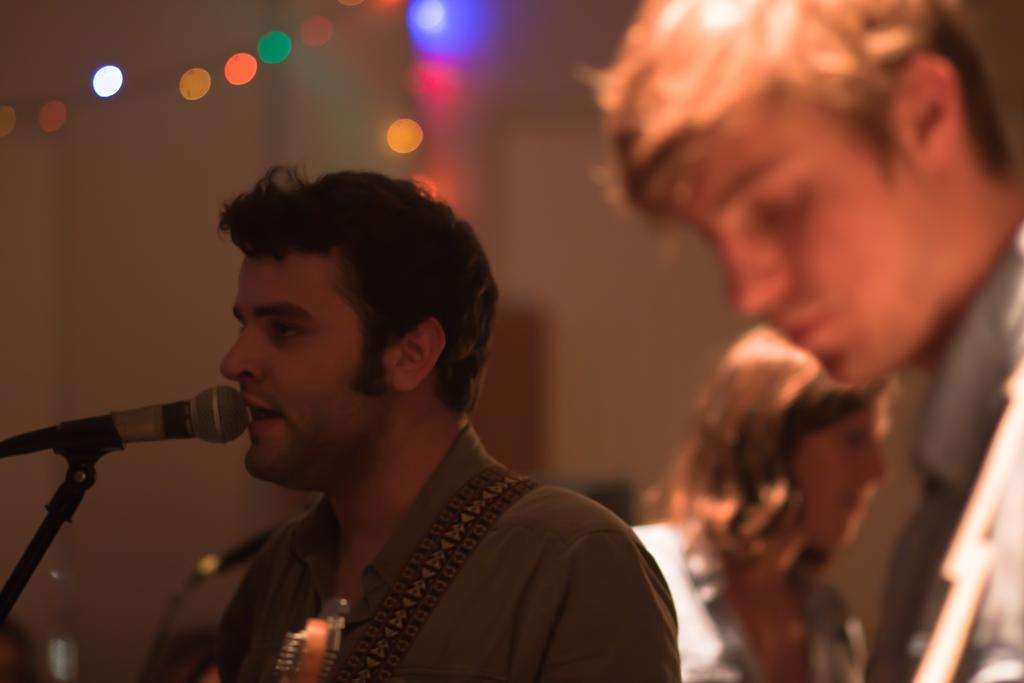What is the man in the image doing? The man is singing in the image. What is the man using while singing? There is a microphone in front of the man. How many other people are visible in the image? There are two persons on the right side of the image. What can be seen at the top of the image? There are lights visible at the top of the image. How would you describe the background of the image? The background of the image is blurry. What type of sweater is the alarm wearing in the image? There is no alarm or sweater present in the image. 